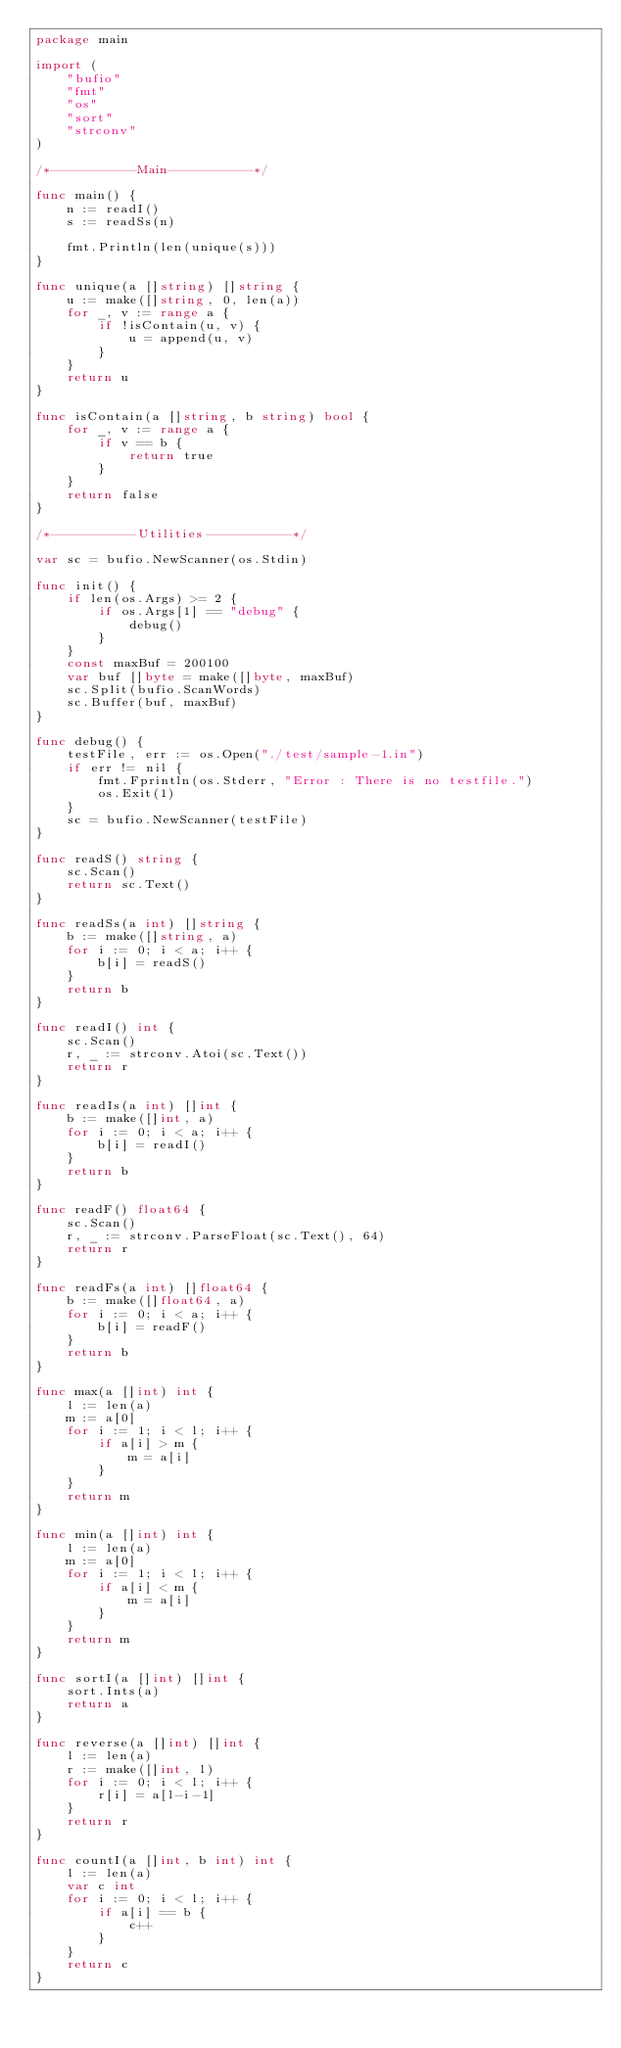<code> <loc_0><loc_0><loc_500><loc_500><_Go_>package main

import (
	"bufio"
	"fmt"
	"os"
	"sort"
	"strconv"
)

/*-----------Main-----------*/

func main() {
	n := readI()
	s := readSs(n)

	fmt.Println(len(unique(s)))
}

func unique(a []string) []string {
	u := make([]string, 0, len(a))
	for _, v := range a {
		if !isContain(u, v) {
			u = append(u, v)
		}
	}
	return u
}

func isContain(a []string, b string) bool {
	for _, v := range a {
		if v == b {
			return true
		}
	}
	return false
}

/*-----------Utilities-----------*/

var sc = bufio.NewScanner(os.Stdin)

func init() {
	if len(os.Args) >= 2 {
		if os.Args[1] == "debug" {
			debug()
		}
	}
	const maxBuf = 200100
	var buf []byte = make([]byte, maxBuf)
	sc.Split(bufio.ScanWords)
	sc.Buffer(buf, maxBuf)
}

func debug() {
	testFile, err := os.Open("./test/sample-1.in")
	if err != nil {
		fmt.Fprintln(os.Stderr, "Error : There is no testfile.")
		os.Exit(1)
	}
	sc = bufio.NewScanner(testFile)
}

func readS() string {
	sc.Scan()
	return sc.Text()
}

func readSs(a int) []string {
	b := make([]string, a)
	for i := 0; i < a; i++ {
		b[i] = readS()
	}
	return b
}

func readI() int {
	sc.Scan()
	r, _ := strconv.Atoi(sc.Text())
	return r
}

func readIs(a int) []int {
	b := make([]int, a)
	for i := 0; i < a; i++ {
		b[i] = readI()
	}
	return b
}

func readF() float64 {
	sc.Scan()
	r, _ := strconv.ParseFloat(sc.Text(), 64)
	return r
}

func readFs(a int) []float64 {
	b := make([]float64, a)
	for i := 0; i < a; i++ {
		b[i] = readF()
	}
	return b
}

func max(a []int) int {
	l := len(a)
	m := a[0]
	for i := 1; i < l; i++ {
		if a[i] > m {
			m = a[i]
		}
	}
	return m
}

func min(a []int) int {
	l := len(a)
	m := a[0]
	for i := 1; i < l; i++ {
		if a[i] < m {
			m = a[i]
		}
	}
	return m
}

func sortI(a []int) []int {
	sort.Ints(a)
	return a
}

func reverse(a []int) []int {
	l := len(a)
	r := make([]int, l)
	for i := 0; i < l; i++ {
		r[i] = a[l-i-1]
	}
	return r
}

func countI(a []int, b int) int {
	l := len(a)
	var c int
	for i := 0; i < l; i++ {
		if a[i] == b {
			c++
		}
	}
	return c
}
</code> 